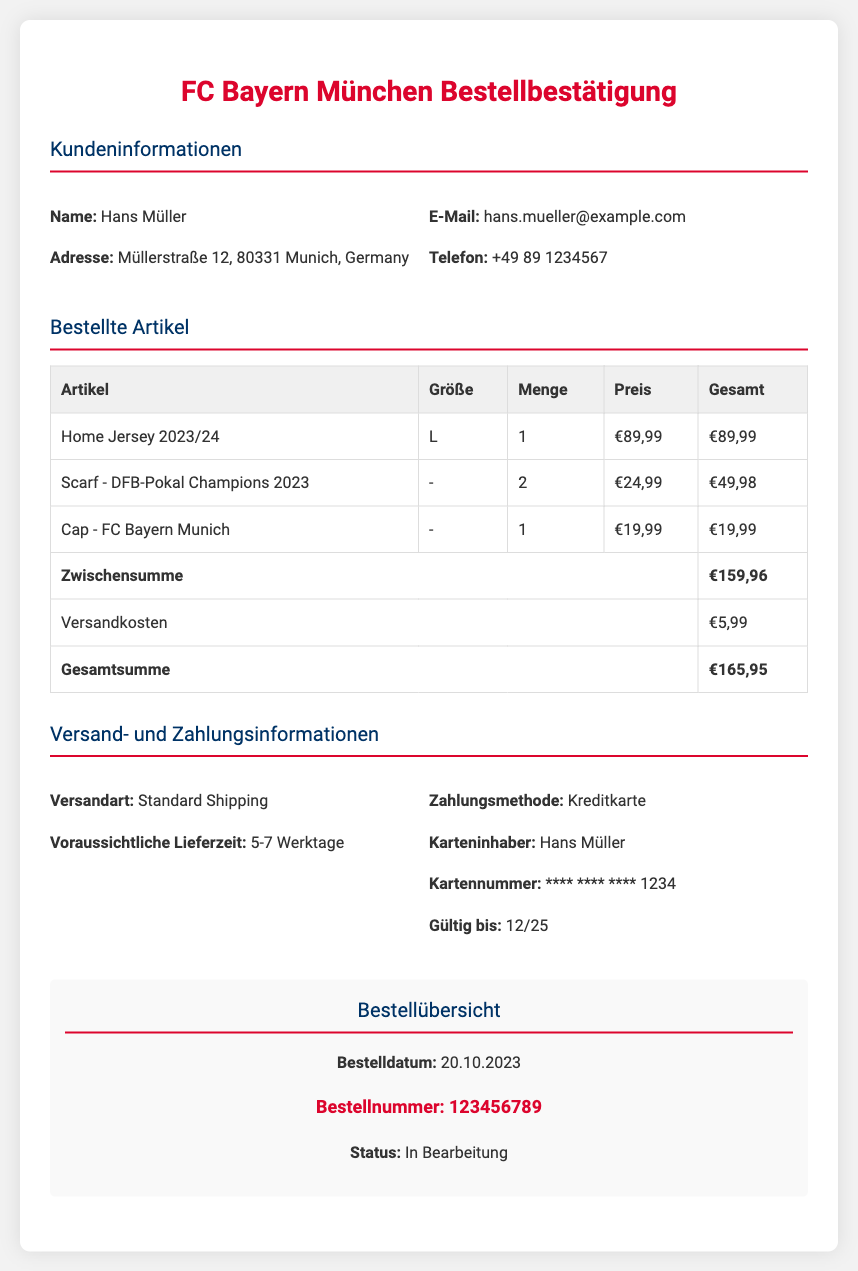What is the name of the customer? The customer's name is listed at the top under customer information.
Answer: Hans Müller What is the total amount for the order? The total amount appears at the bottom of the itemized costs table.
Answer: €165,95 How many "Scarf - DFB-Pokal Champions 2023" were ordered? The quantity for the scarf is specified in the quantity column of the itemized list.
Answer: 2 What is the estimated delivery time? The delivery time is mentioned in the shipping information section of the document.
Answer: 5-7 Werktage What is the payment method used for this order? The payment method is outlined in the shipping and payment information section.
Answer: Kreditkarte What is the subtotal before shipping costs? The subtotal can be found in the itemized costs right before shipping fees.
Answer: €159,96 What is the shipping cost? The shipping cost is detailed in the itemized costs table.
Answer: €5,99 What is the order number? The order number is prominently displayed in the order summary section.
Answer: 123456789 What date was the order placed? The order date is specified in the order summary section below the order number.
Answer: 20.10.2023 